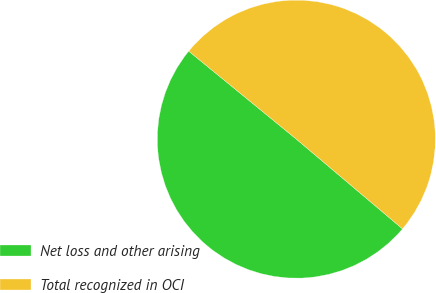Convert chart to OTSL. <chart><loc_0><loc_0><loc_500><loc_500><pie_chart><fcel>Net loss and other arising<fcel>Total recognized in OCI<nl><fcel>49.74%<fcel>50.26%<nl></chart> 